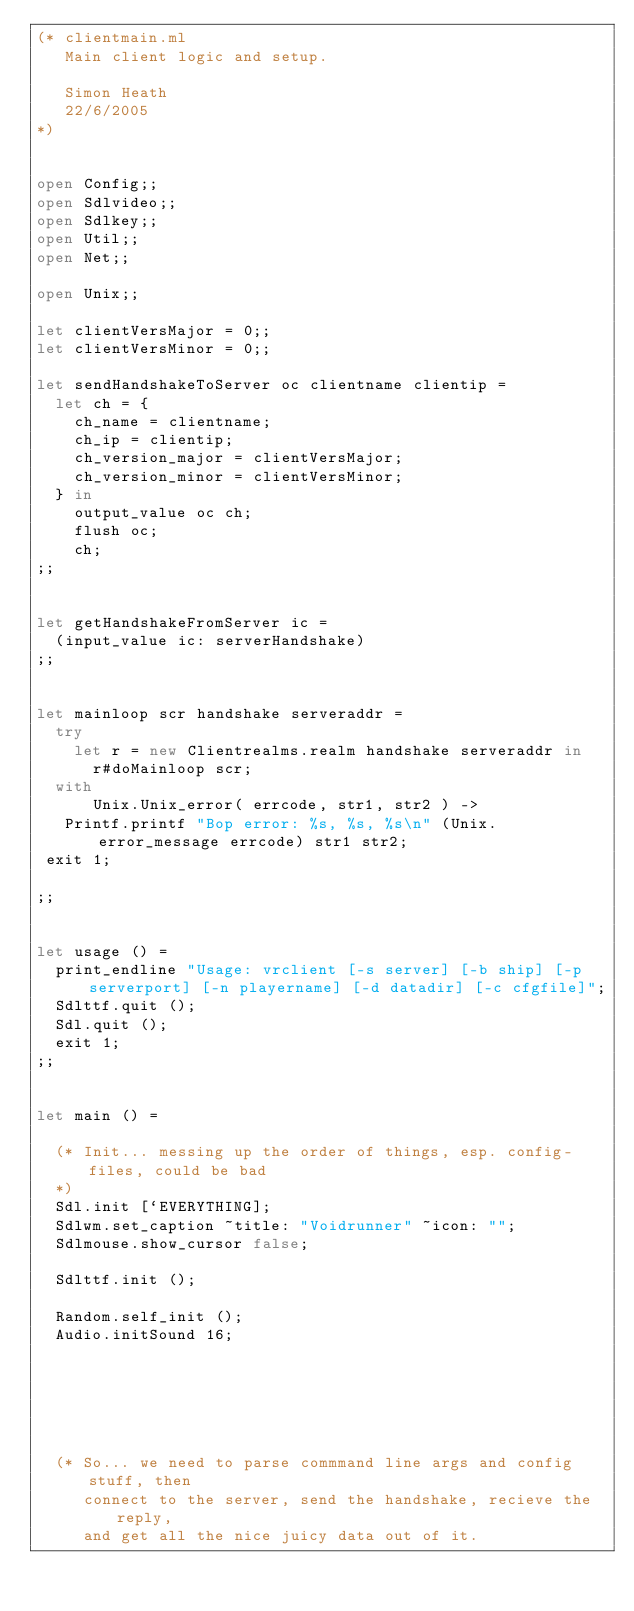Convert code to text. <code><loc_0><loc_0><loc_500><loc_500><_OCaml_>(* clientmain.ml
   Main client logic and setup.

   Simon Heath
   22/6/2005
*)


open Config;;
open Sdlvideo;;
open Sdlkey;;
open Util;;
open Net;;

open Unix;;

let clientVersMajor = 0;;
let clientVersMinor = 0;;

let sendHandshakeToServer oc clientname clientip =
  let ch = {
    ch_name = clientname;
    ch_ip = clientip;
    ch_version_major = clientVersMajor;
    ch_version_minor = clientVersMinor;
  } in
    output_value oc ch;
    flush oc;
    ch;
;;


let getHandshakeFromServer ic =
  (input_value ic: serverHandshake)
;;


let mainloop scr handshake serveraddr =
  try
    let r = new Clientrealms.realm handshake serveraddr in
      r#doMainloop scr;
  with
      Unix.Unix_error( errcode, str1, str2 ) ->
   Printf.printf "Bop error: %s, %s, %s\n" (Unix.error_message errcode) str1 str2;
 exit 1;

;;


let usage () =
  print_endline "Usage: vrclient [-s server] [-b ship] [-p serverport] [-n playername] [-d datadir] [-c cfgfile]";
  Sdlttf.quit ();
  Sdl.quit ();
  exit 1;
;;


let main () =

  (* Init... messing up the order of things, esp. config-files, could be bad
  *)
  Sdl.init [`EVERYTHING];
  Sdlwm.set_caption ~title: "Voidrunner" ~icon: "";
  Sdlmouse.show_cursor false;

  Sdlttf.init ();

  Random.self_init ();
  Audio.initSound 16; 






  (* So... we need to parse commmand line args and config stuff, then
     connect to the server, send the handshake, recieve the reply,
     and get all the nice juicy data out of it.</code> 